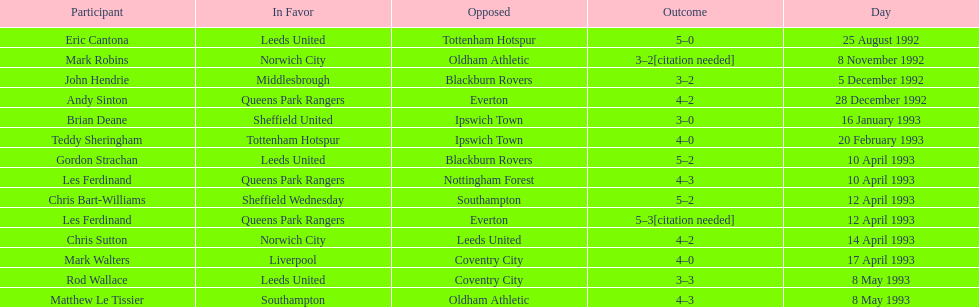Which team did liverpool play against? Coventry City. 